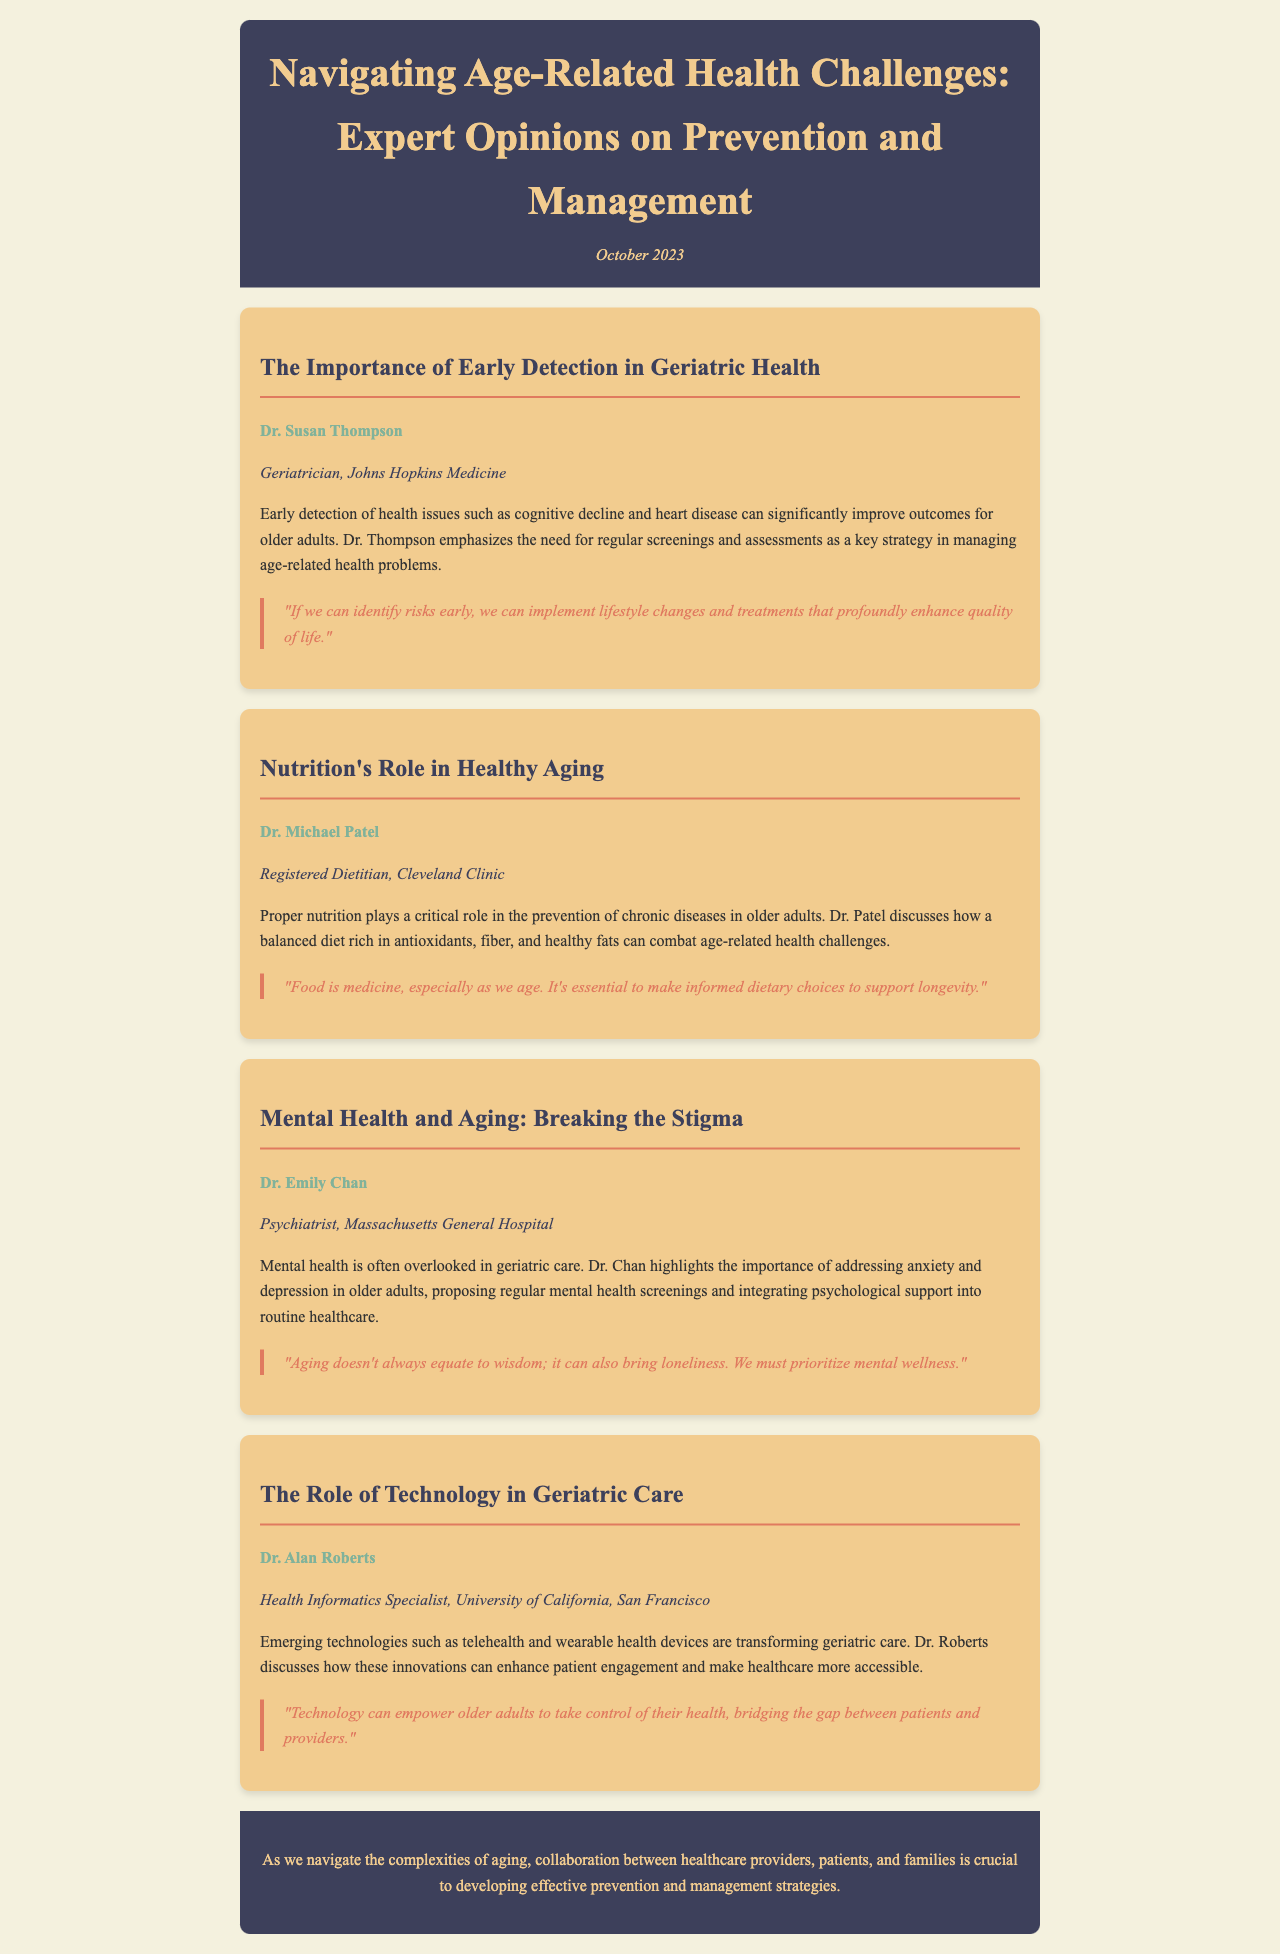What is the title of the newsletter? The title of the newsletter is prominently displayed at the top of the document under the header section.
Answer: Navigating Age-Related Health Challenges: Expert Opinions on Prevention and Management Who is the author of the article about early detection? The author is mentioned next to the article title, indicating their expertise and affiliation.
Answer: Dr. Susan Thompson What is the publication date of the newsletter? The publication date is noted in the header, providing context for the content presented.
Answer: October 2023 Which health issue is emphasized by Dr. Thompson in her article? The specific health issue mentioned in Dr. Thompson's article highlights the focus on geriatric health.
Answer: Cognitive decline and heart disease What is the primary focus of Dr. Patel's discussion? The focus of Dr. Patel's article is outlined in the text describing the importance of dietary choices for older adults.
Answer: Nutrition What technology does Dr. Roberts mention in his article? Dr. Roberts discusses specific innovations in the healthcare field, which are highlighted in his article.
Answer: Telehealth and wearable health devices Which mental health issues does Dr. Chan address in her article? Dr. Chan's article includes specific mental health concerns that are prevalent in older adults.
Answer: Anxiety and depression What role does the newsletter suggest for collaboration in geriatric care? The conclusion of the newsletter emphasizes the importance of teamwork among different stakeholders in healthcare.
Answer: Developing effective prevention and management strategies 